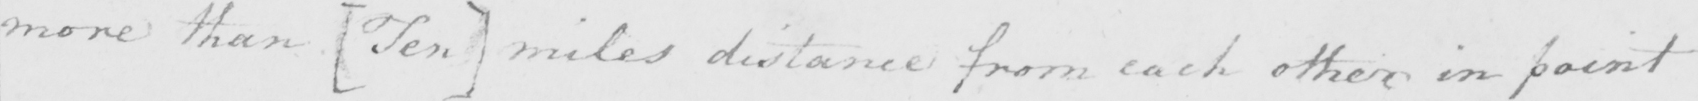Please provide the text content of this handwritten line. more than [Ten] miles distance from each other in point 